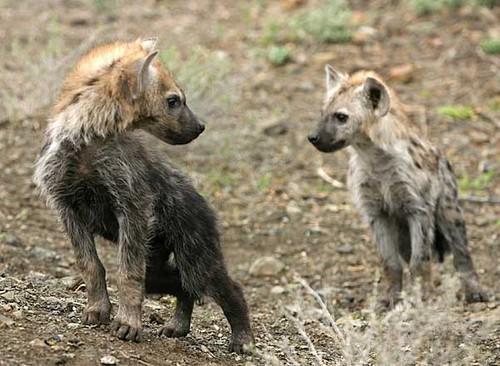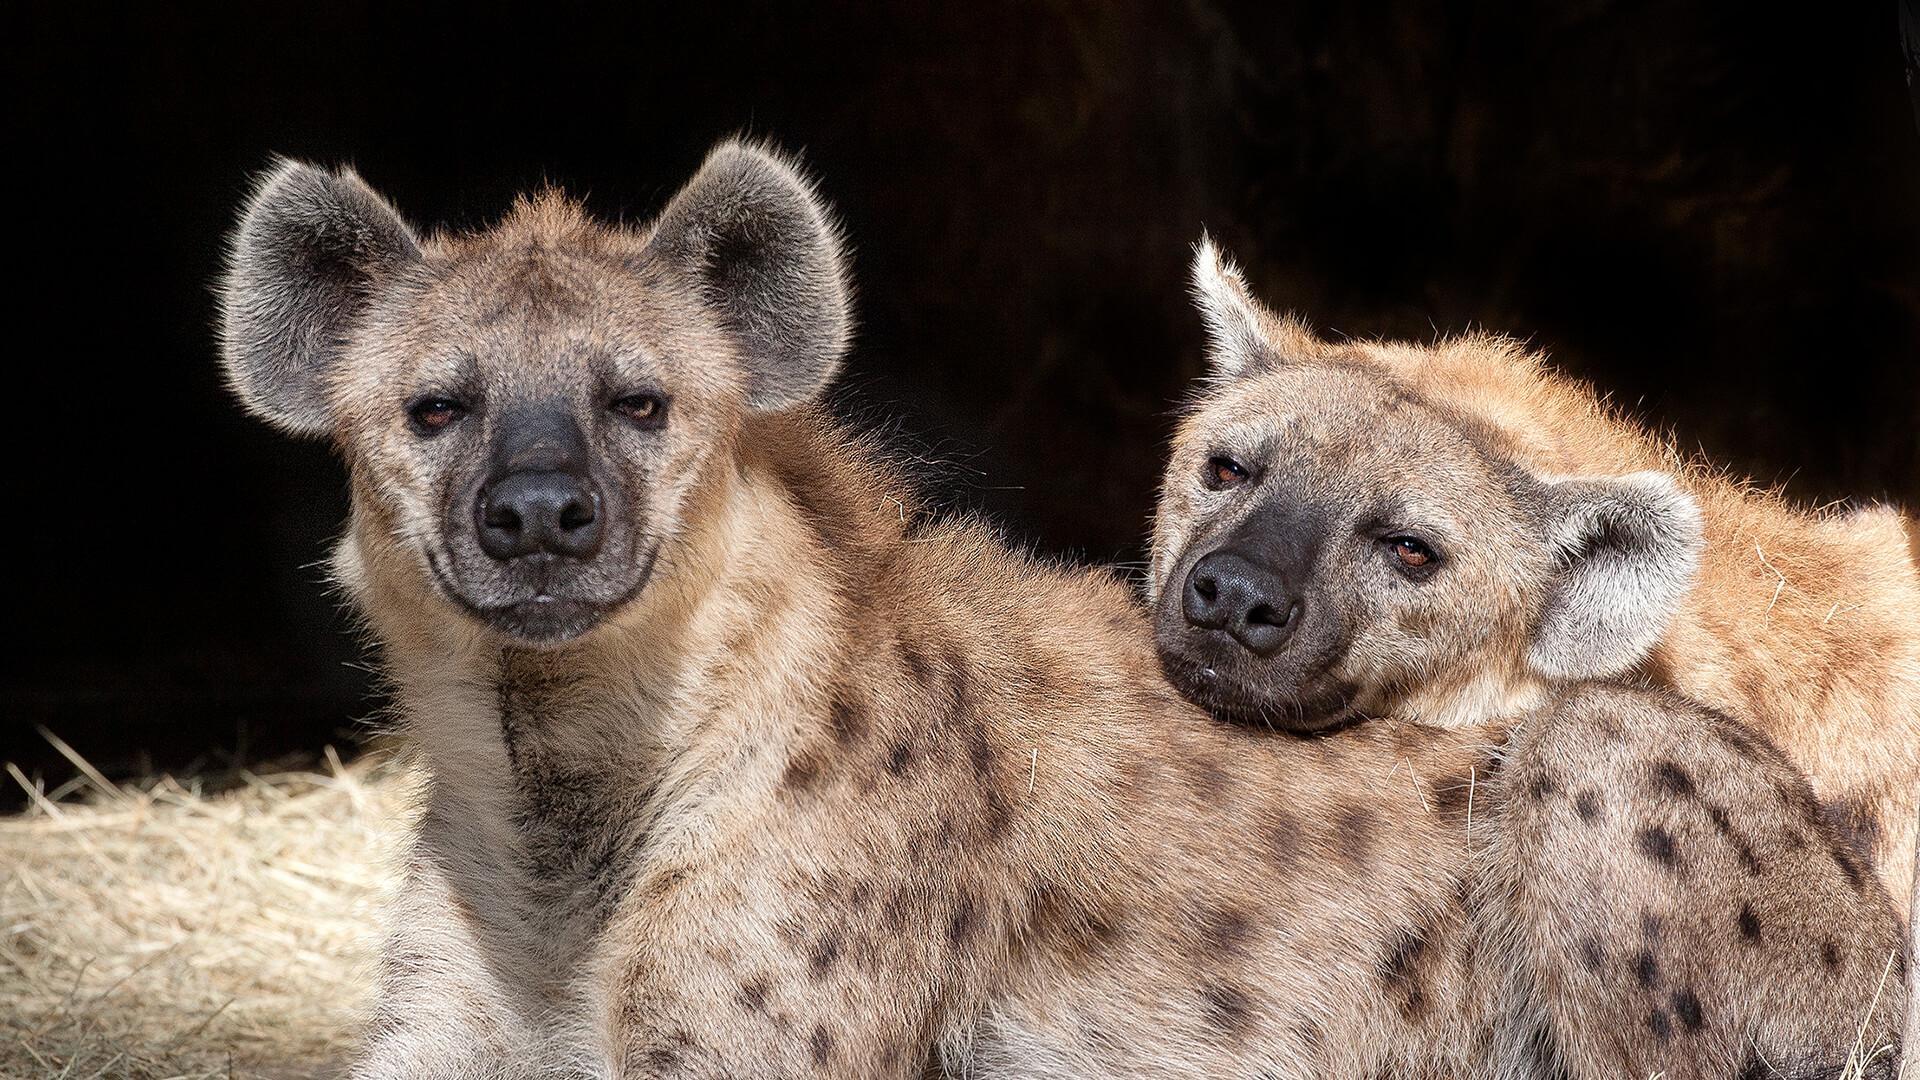The first image is the image on the left, the second image is the image on the right. Examine the images to the left and right. Is the description "There are hyena cubs laying with their moms" accurate? Answer yes or no. No. The first image is the image on the left, the second image is the image on the right. For the images displayed, is the sentence "An image shows an adult hyena lying with a much younger hyena." factually correct? Answer yes or no. No. 